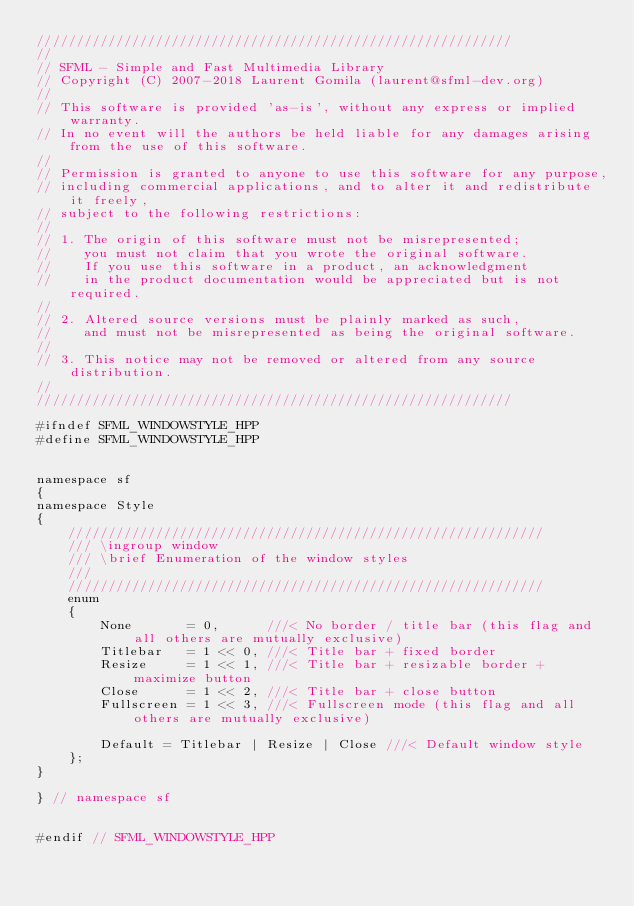Convert code to text. <code><loc_0><loc_0><loc_500><loc_500><_C++_>////////////////////////////////////////////////////////////
//
// SFML - Simple and Fast Multimedia Library
// Copyright (C) 2007-2018 Laurent Gomila (laurent@sfml-dev.org)
//
// This software is provided 'as-is', without any express or implied warranty.
// In no event will the authors be held liable for any damages arising from the use of this software.
//
// Permission is granted to anyone to use this software for any purpose,
// including commercial applications, and to alter it and redistribute it freely,
// subject to the following restrictions:
//
// 1. The origin of this software must not be misrepresented;
//    you must not claim that you wrote the original software.
//    If you use this software in a product, an acknowledgment
//    in the product documentation would be appreciated but is not required.
//
// 2. Altered source versions must be plainly marked as such,
//    and must not be misrepresented as being the original software.
//
// 3. This notice may not be removed or altered from any source distribution.
//
////////////////////////////////////////////////////////////

#ifndef SFML_WINDOWSTYLE_HPP
#define SFML_WINDOWSTYLE_HPP


namespace sf
{
namespace Style
{
    ////////////////////////////////////////////////////////////
    /// \ingroup window
    /// \brief Enumeration of the window styles
    ///
    ////////////////////////////////////////////////////////////
    enum
    {
        None       = 0,      ///< No border / title bar (this flag and all others are mutually exclusive)
        Titlebar   = 1 << 0, ///< Title bar + fixed border
        Resize     = 1 << 1, ///< Title bar + resizable border + maximize button
        Close      = 1 << 2, ///< Title bar + close button
        Fullscreen = 1 << 3, ///< Fullscreen mode (this flag and all others are mutually exclusive)

        Default = Titlebar | Resize | Close ///< Default window style
    };
}

} // namespace sf


#endif // SFML_WINDOWSTYLE_HPP
</code> 